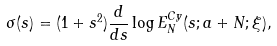Convert formula to latex. <formula><loc_0><loc_0><loc_500><loc_500>\sigma ( s ) = ( 1 + s ^ { 2 } ) \frac { d } { d s } \log E ^ { C y } _ { N } ( s ; a + N ; \xi ) ,</formula> 